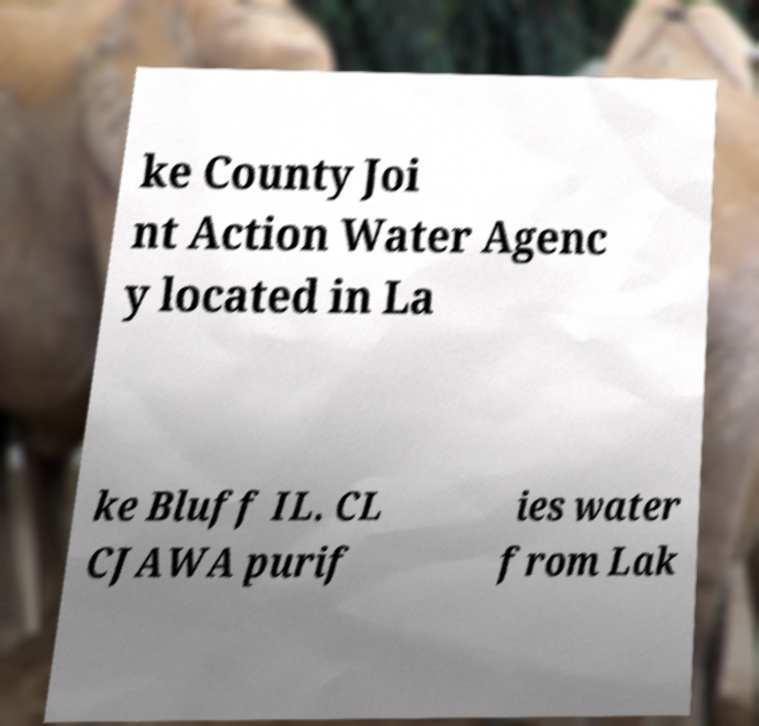Can you read and provide the text displayed in the image?This photo seems to have some interesting text. Can you extract and type it out for me? ke County Joi nt Action Water Agenc y located in La ke Bluff IL. CL CJAWA purif ies water from Lak 